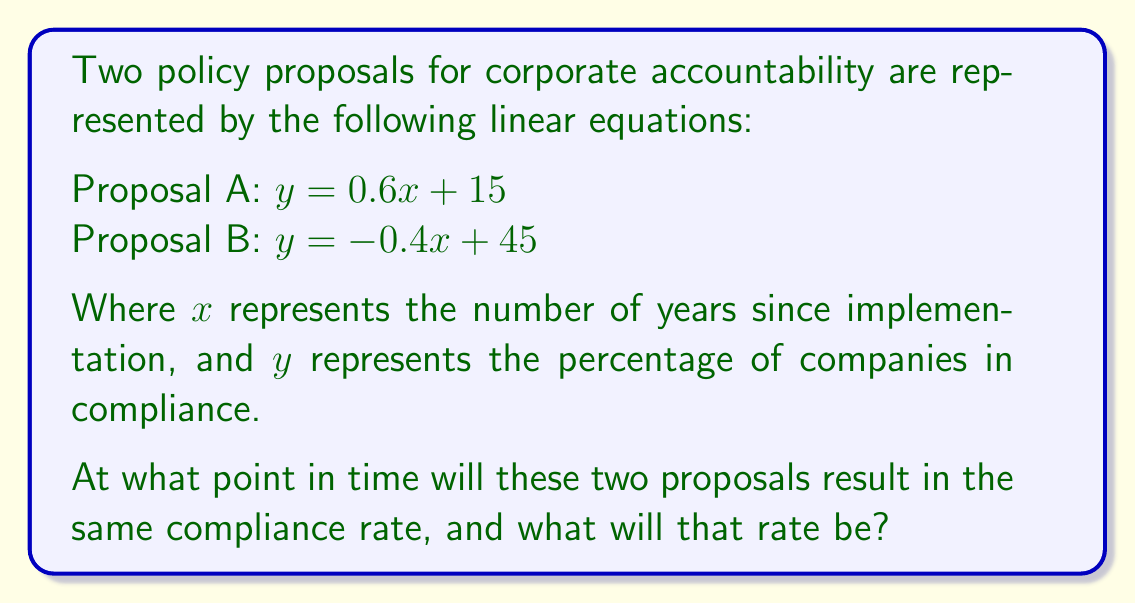Could you help me with this problem? To find the intersection point of these two linear equations, we need to solve them simultaneously:

1) Set the equations equal to each other:
   $0.6x + 15 = -0.4x + 45$

2) Solve for $x$:
   $0.6x + 0.4x = 45 - 15$
   $x = 30$

3) Substitute this $x$ value into either equation to find $y$:
   Using Proposal A: $y = 0.6(30) + 15$
   $y = 18 + 15 = 33$

4) Therefore, the intersection point is $(30, 33)$

5) Interpret the result:
   - The proposals will result in the same compliance rate after 30 years.
   - At that time, the compliance rate will be 33%.
Answer: $(30, 33)$; After 30 years, 33% compliance rate 